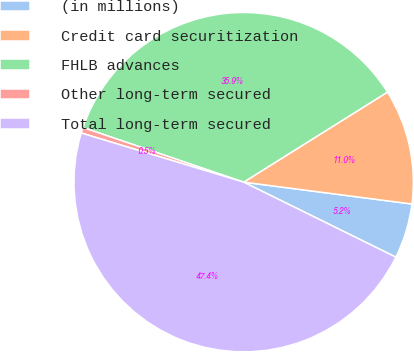<chart> <loc_0><loc_0><loc_500><loc_500><pie_chart><fcel>(in millions)<fcel>Credit card securitization<fcel>FHLB advances<fcel>Other long-term secured<fcel>Total long-term secured<nl><fcel>5.23%<fcel>10.96%<fcel>35.88%<fcel>0.54%<fcel>47.39%<nl></chart> 